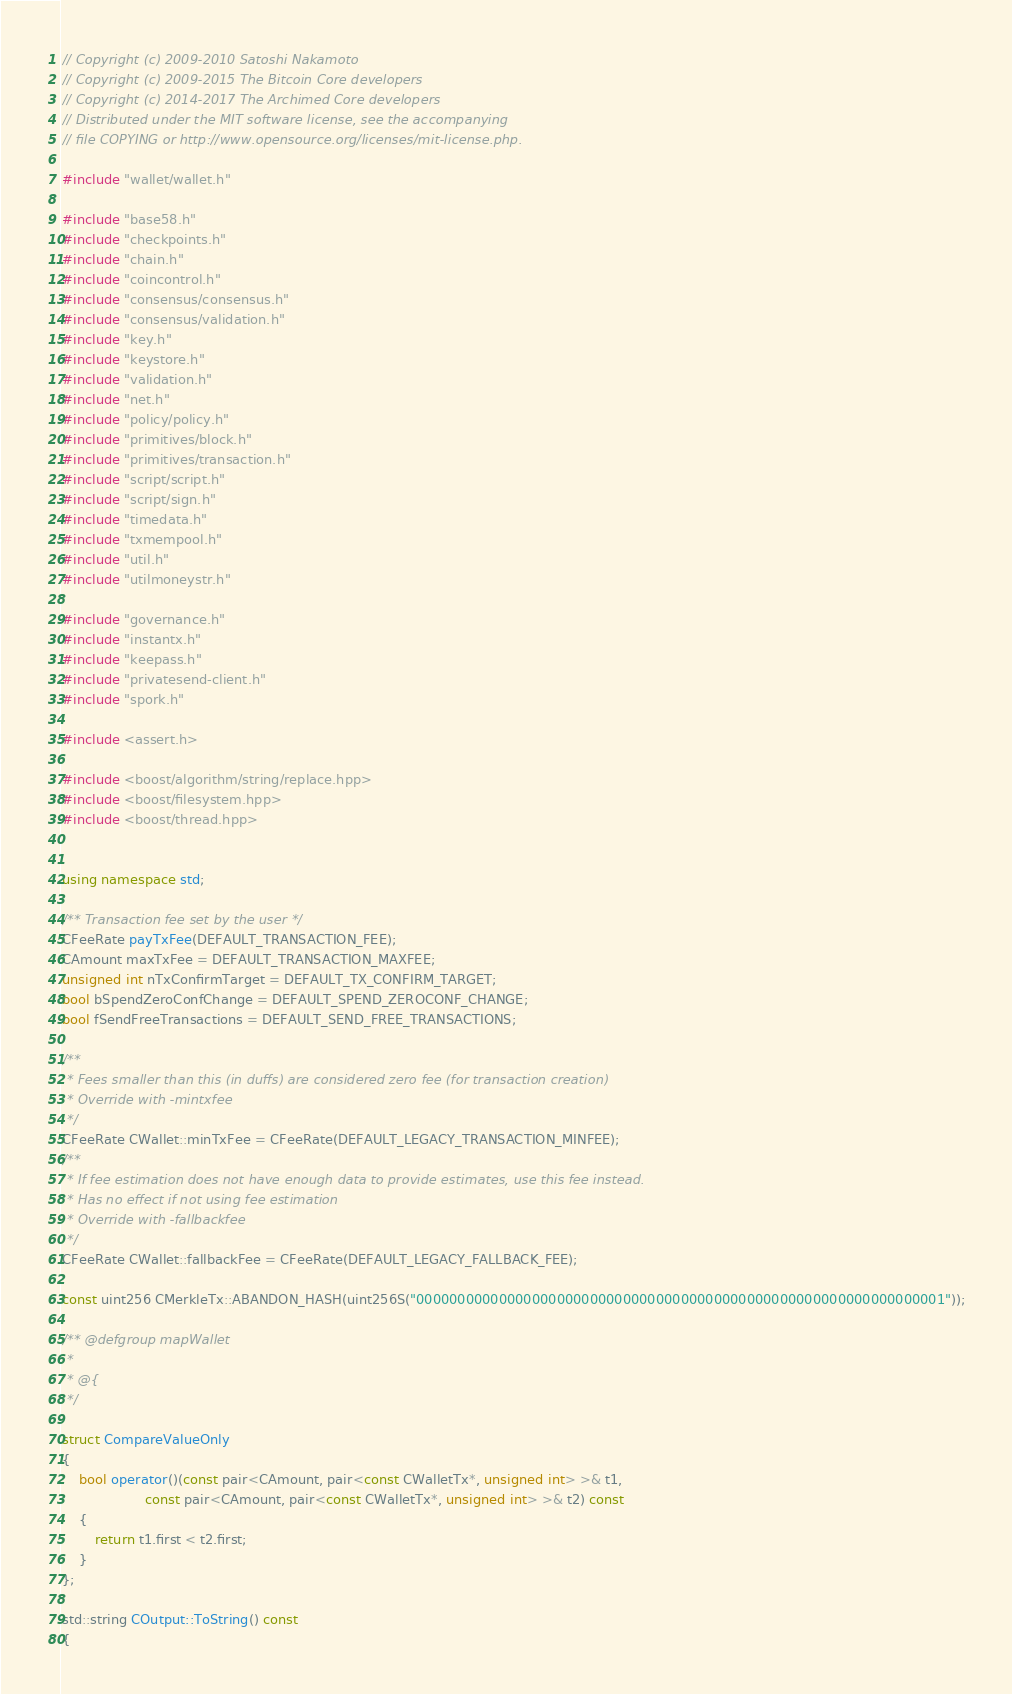Convert code to text. <code><loc_0><loc_0><loc_500><loc_500><_C++_>// Copyright (c) 2009-2010 Satoshi Nakamoto
// Copyright (c) 2009-2015 The Bitcoin Core developers
// Copyright (c) 2014-2017 The Archimed Core developers
// Distributed under the MIT software license, see the accompanying
// file COPYING or http://www.opensource.org/licenses/mit-license.php.

#include "wallet/wallet.h"

#include "base58.h"
#include "checkpoints.h"
#include "chain.h"
#include "coincontrol.h"
#include "consensus/consensus.h"
#include "consensus/validation.h"
#include "key.h"
#include "keystore.h"
#include "validation.h"
#include "net.h"
#include "policy/policy.h"
#include "primitives/block.h"
#include "primitives/transaction.h"
#include "script/script.h"
#include "script/sign.h"
#include "timedata.h"
#include "txmempool.h"
#include "util.h"
#include "utilmoneystr.h"

#include "governance.h"
#include "instantx.h"
#include "keepass.h"
#include "privatesend-client.h"
#include "spork.h"

#include <assert.h>

#include <boost/algorithm/string/replace.hpp>
#include <boost/filesystem.hpp>
#include <boost/thread.hpp>


using namespace std;

/** Transaction fee set by the user */
CFeeRate payTxFee(DEFAULT_TRANSACTION_FEE);
CAmount maxTxFee = DEFAULT_TRANSACTION_MAXFEE;
unsigned int nTxConfirmTarget = DEFAULT_TX_CONFIRM_TARGET;
bool bSpendZeroConfChange = DEFAULT_SPEND_ZEROCONF_CHANGE;
bool fSendFreeTransactions = DEFAULT_SEND_FREE_TRANSACTIONS;

/**
 * Fees smaller than this (in duffs) are considered zero fee (for transaction creation)
 * Override with -mintxfee
 */
CFeeRate CWallet::minTxFee = CFeeRate(DEFAULT_LEGACY_TRANSACTION_MINFEE);
/**
 * If fee estimation does not have enough data to provide estimates, use this fee instead.
 * Has no effect if not using fee estimation
 * Override with -fallbackfee
 */
CFeeRate CWallet::fallbackFee = CFeeRate(DEFAULT_LEGACY_FALLBACK_FEE);

const uint256 CMerkleTx::ABANDON_HASH(uint256S("0000000000000000000000000000000000000000000000000000000000000001"));

/** @defgroup mapWallet
 *
 * @{
 */

struct CompareValueOnly
{
    bool operator()(const pair<CAmount, pair<const CWalletTx*, unsigned int> >& t1,
                    const pair<CAmount, pair<const CWalletTx*, unsigned int> >& t2) const
    {
        return t1.first < t2.first;
    }
};

std::string COutput::ToString() const
{</code> 